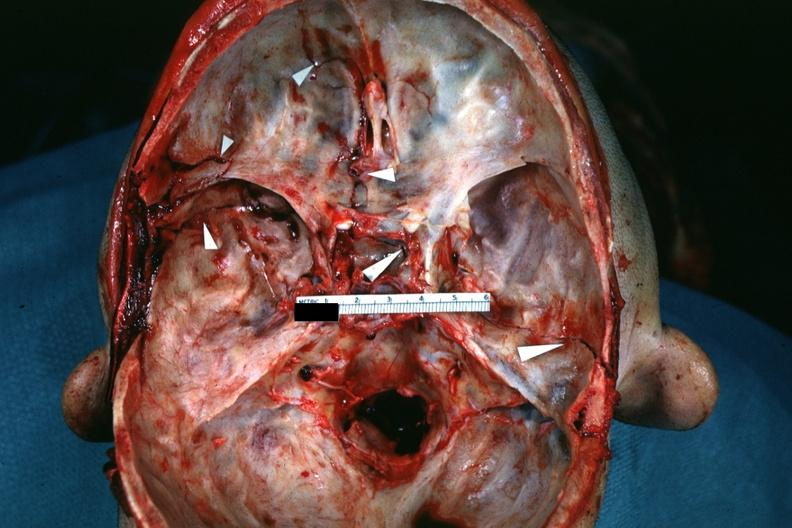s acid present?
Answer the question using a single word or phrase. No 